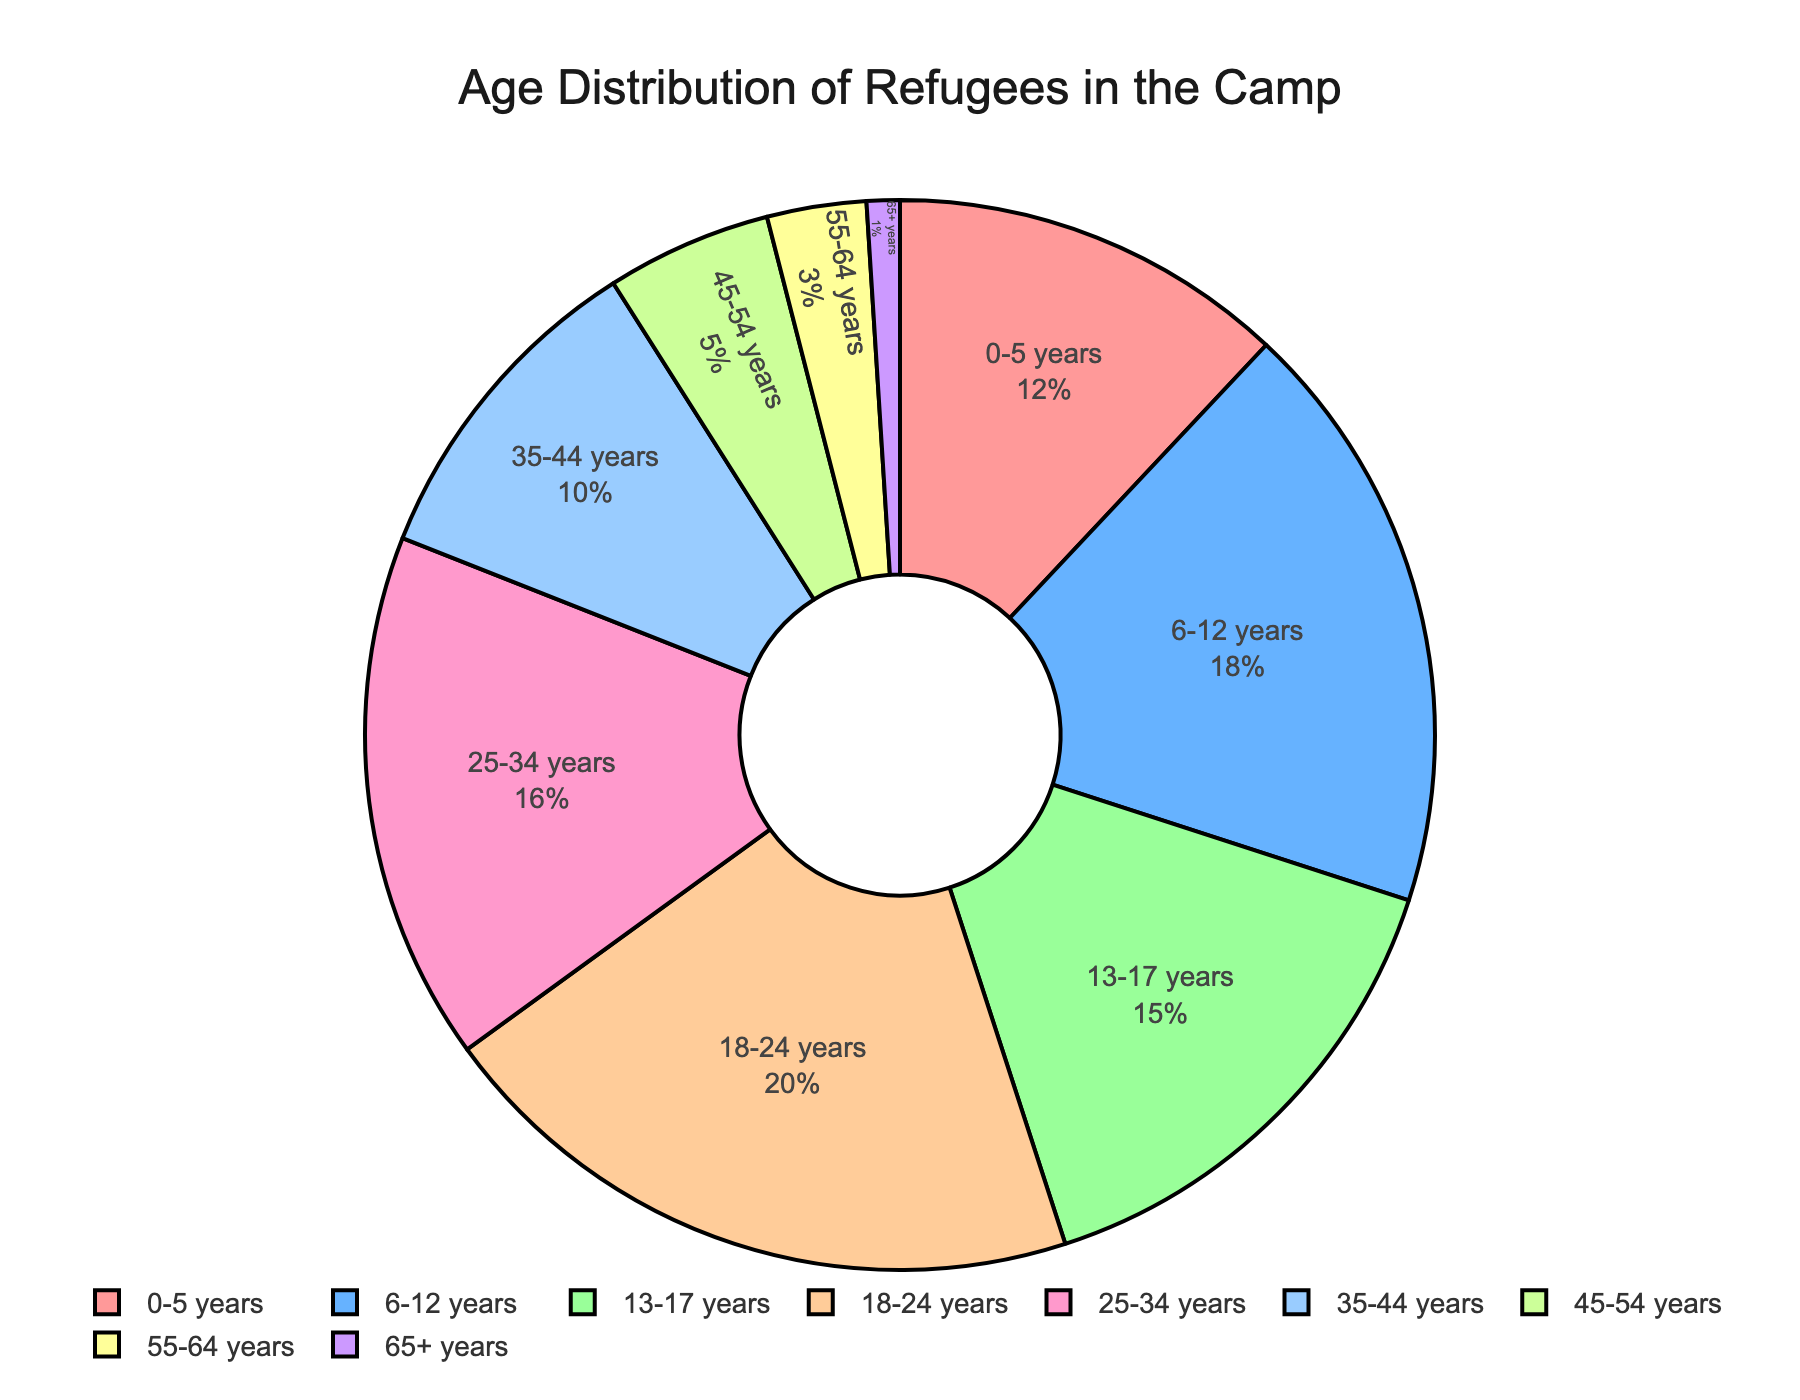What percentage of refugees are aged 18-24 years? To find the percentage of refugees aged 18-24 years, you can directly refer to the segment labeled "18-24 years" in the pie chart. It shows the percentage as 20%.
Answer: 20% Which age group has the smallest percentage of refugees? By looking at the pie chart, you can identify the age group labeled "65+ years" as the smallest segment, indicating it has the smallest percentage.
Answer: 65+ years What is the combined percentage of refugees aged 0-17 years? Add the percentages of the age groups "0-5 years" (12%), "6-12 years" (18%), and "13-17 years" (15%). So, 12% + 18% + 15% = 45%.
Answer: 45% How does the percentage of refugees aged 25-34 years compare to those aged 18-24 years? The chart shows that the percentage for the "25-34 years" group is 16%, while the percentage for the "18-24 years" group is 20%. Since 16% is less than 20%, the refugees aged 25-34 years is lesser.
Answer: Lesser What age groups together make up a cumulative 45% of the refugee population? According to the cumulative percentages in the pie chart's hover text, the groups "0-5 years" (12%), "6-12 years" (18%), and "13-17 years" (15%) sum up to a cumulative percentage of 45%.
Answer: 0-5 years, 6-12 years, 13-17 years Which age group is represented by the color green in the pie chart? The pie chart uses different colors for each age group. From the provided colors list, "13-17 years" corresponds to green. Verify this by checking the chart.
Answer: 13-17 years What is the percentage difference between the groups 35-44 years and 45-54 years? Subtract the percentage of the "45-54 years" group (5%) from the "35-44 years" group (10%). So, 10% - 5% = 5%.
Answer: 5% 